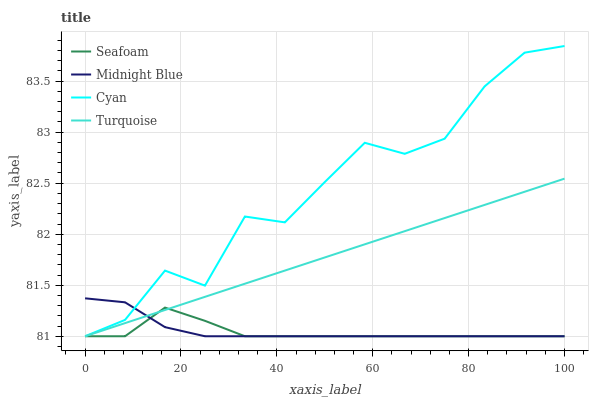Does Turquoise have the minimum area under the curve?
Answer yes or no. No. Does Turquoise have the maximum area under the curve?
Answer yes or no. No. Is Seafoam the smoothest?
Answer yes or no. No. Is Seafoam the roughest?
Answer yes or no. No. Does Turquoise have the highest value?
Answer yes or no. No. 